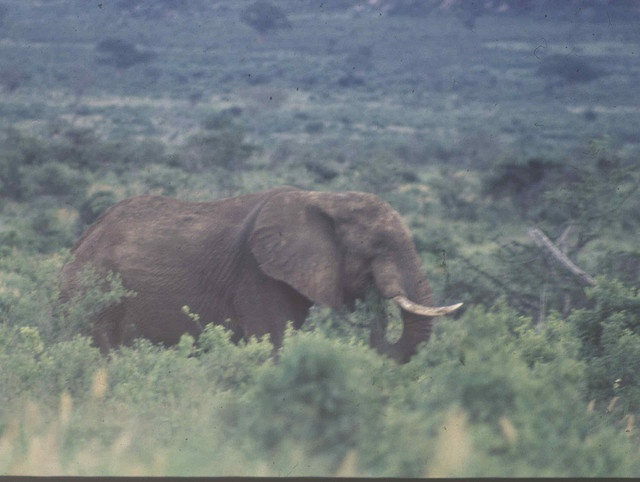Describe the objects in this image and their specific colors. I can see a elephant in gray tones in this image. 